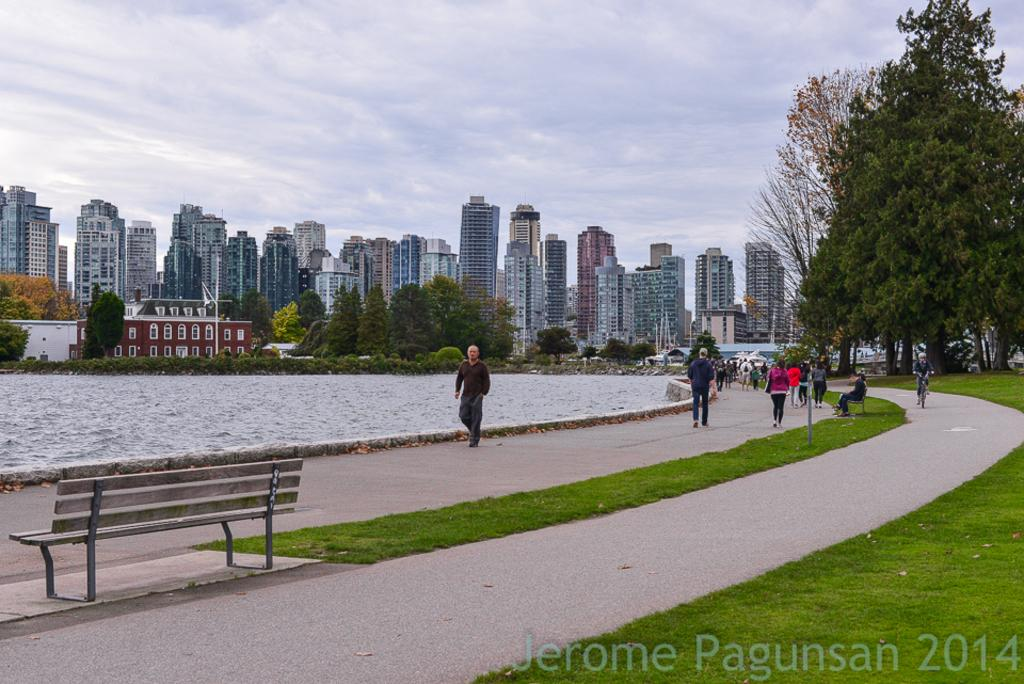What is the weather like in the image? The sky is cloudy in the image. Can you describe the people in the image? There are people in the image, but their specific actions or appearances are not mentioned in the facts. What type of seating is present in the image? There is a bench in the image. What natural elements can be seen in the image? Water and grass are visible in the image. What can be seen in the background of the image? There are buildings and trees in the background of the image. Is there any additional information about the image itself? Yes, there is a watermark at the bottom of the image. How many roses are being held by the people in the image? There is no mention of roses in the image, so it is impossible to determine how many are being held. What type of cable is being used to connect the buildings in the background? There is no mention of cables connecting the buildings in the background, so it is impossible to determine the type of cable being used. 